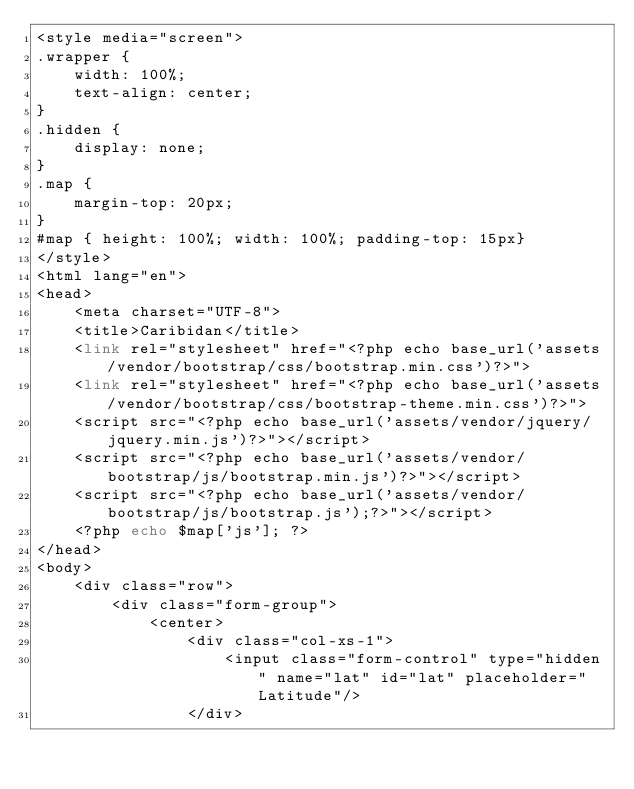Convert code to text. <code><loc_0><loc_0><loc_500><loc_500><_PHP_><style media="screen">
.wrapper {
    width: 100%;
    text-align: center;
}
.hidden {
    display: none;
}
.map {
    margin-top: 20px;
}
#map { height: 100%; width: 100%; padding-top: 15px}
</style>
<html lang="en">
<head>
    <meta charset="UTF-8">
    <title>Caribidan</title>
    <link rel="stylesheet" href="<?php echo base_url('assets/vendor/bootstrap/css/bootstrap.min.css')?>">
    <link rel="stylesheet" href="<?php echo base_url('assets/vendor/bootstrap/css/bootstrap-theme.min.css')?>">
    <script src="<?php echo base_url('assets/vendor/jquery/jquery.min.js')?>"></script>
    <script src="<?php echo base_url('assets/vendor/bootstrap/js/bootstrap.min.js')?>"></script>
    <script src="<?php echo base_url('assets/vendor/bootstrap/js/bootstrap.js');?>"></script>
    <?php echo $map['js']; ?>
</head>
<body>
    <div class="row">
        <div class="form-group">
            <center>
                <div class="col-xs-1">
                    <input class="form-control" type="hidden" name="lat" id="lat" placeholder="Latitude"/>
                </div></code> 